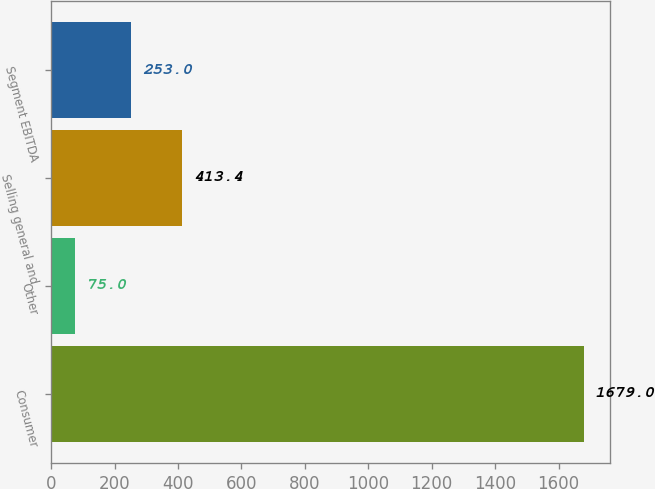Convert chart to OTSL. <chart><loc_0><loc_0><loc_500><loc_500><bar_chart><fcel>Consumer<fcel>Other<fcel>Selling general and<fcel>Segment EBITDA<nl><fcel>1679<fcel>75<fcel>413.4<fcel>253<nl></chart> 